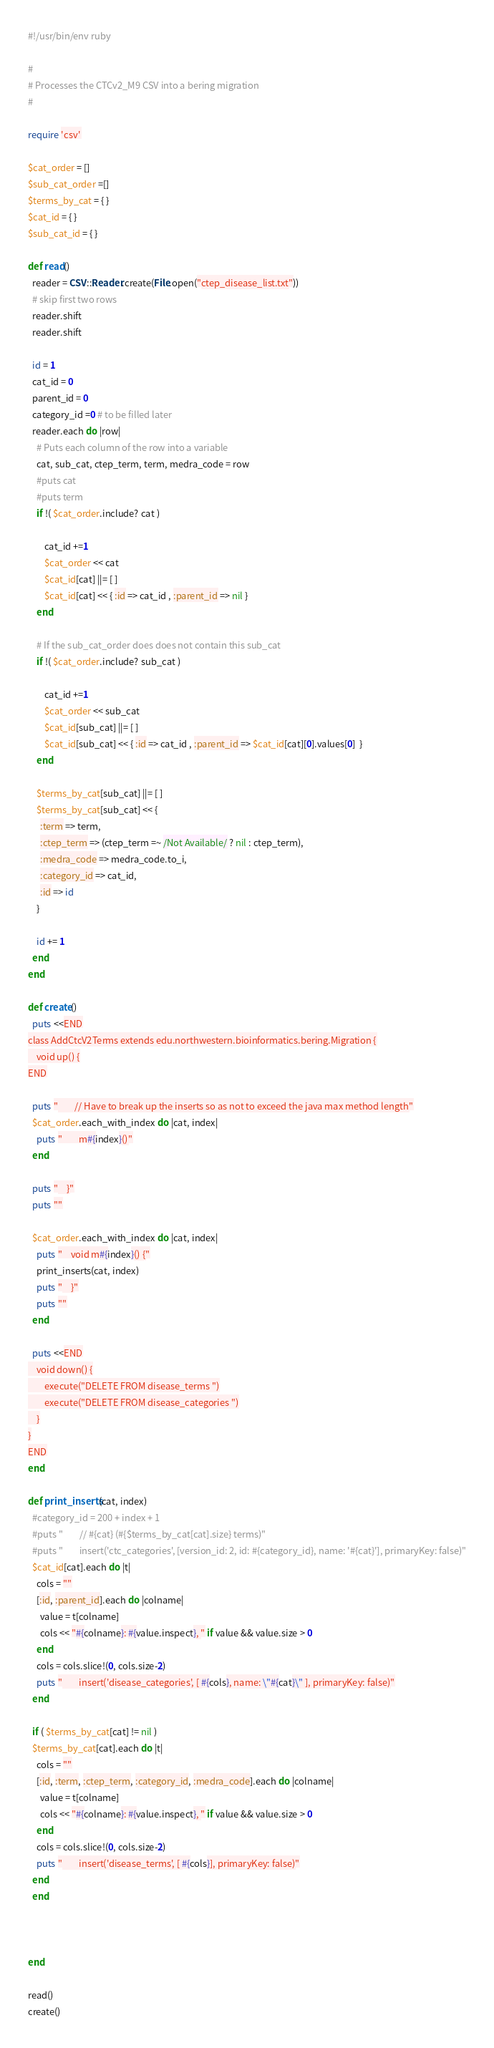<code> <loc_0><loc_0><loc_500><loc_500><_Ruby_>#!/usr/bin/env ruby

#
# Processes the CTCv2_M9 CSV into a bering migration
#

require 'csv'

$cat_order = []
$sub_cat_order =[]
$terms_by_cat = { }
$cat_id = { }
$sub_cat_id = { }

def read()
  reader = CSV::Reader.create(File.open("ctep_disease_list.txt"))
  # skip first two rows
  reader.shift
  reader.shift
  
  id = 1
  cat_id = 0
  parent_id = 0
  category_id =0 # to be filled later
  reader.each do |row|
    # Puts each column of the row into a variable
    cat, sub_cat, ctep_term, term, medra_code = row
    #puts cat
    #puts term
    if !( $cat_order.include? cat )
       
        cat_id +=1
        $cat_order << cat
        $cat_id[cat] ||= [ ]
        $cat_id[cat] << { :id => cat_id , :parent_id => nil }
    end
    
    # If the sub_cat_order does does not contain this sub_cat
    if !( $cat_order.include? sub_cat )
        
        cat_id +=1
        $cat_order << sub_cat
        $cat_id[sub_cat] ||= [ ]
        $cat_id[sub_cat] << { :id => cat_id , :parent_id => $cat_id[cat][0].values[0]  }
    end
    
    $terms_by_cat[sub_cat] ||= [ ]
    $terms_by_cat[sub_cat] << { 
      :term => term, 
      :ctep_term => (ctep_term =~ /Not Available/ ? nil : ctep_term), 
      :medra_code => medra_code.to_i,
      :category_id => cat_id,
      :id => id
    }
   
    id += 1
  end
end

def create()
  puts <<END
class AddCtcV2Terms extends edu.northwestern.bioinformatics.bering.Migration {
    void up() {
END

  puts "        // Have to break up the inserts so as not to exceed the java max method length"
  $cat_order.each_with_index do |cat, index|
    puts "        m#{index}()"
  end

  puts "    }"
  puts ""
  
  $cat_order.each_with_index do |cat, index|
    puts "    void m#{index}() {"
    print_inserts(cat, index)
    puts "    }"
    puts ""
  end

  puts <<END
    void down() {
        execute("DELETE FROM disease_terms ")
        execute("DELETE FROM disease_categories ")
    }
}
END
end

def print_inserts(cat, index)
  #category_id = 200 + index + 1
  #puts "        // #{cat} (#{$terms_by_cat[cat].size} terms)"
  #puts "        insert('ctc_categories', [version_id: 2, id: #{category_id}, name: '#{cat}'], primaryKey: false)"
  $cat_id[cat].each do |t|
    cols = ""
    [:id, :parent_id].each do |colname|
      value = t[colname]
      cols << "#{colname}: #{value.inspect}, " if value && value.size > 0
    end
    cols = cols.slice!(0, cols.size-2)
    puts "        insert('disease_categories', [ #{cols}, name: \"#{cat}\" ], primaryKey: false)"
  end
  
  if ( $terms_by_cat[cat] != nil )
  $terms_by_cat[cat].each do |t|
    cols = ""
    [:id, :term, :ctep_term, :category_id, :medra_code].each do |colname|
      value = t[colname]
      cols << "#{colname}: #{value.inspect}, " if value && value.size > 0
    end
    cols = cols.slice!(0, cols.size-2)
    puts "        insert('disease_terms', [ #{cols}], primaryKey: false)"
  end
  end
  
  
 
end

read()
create()
</code> 